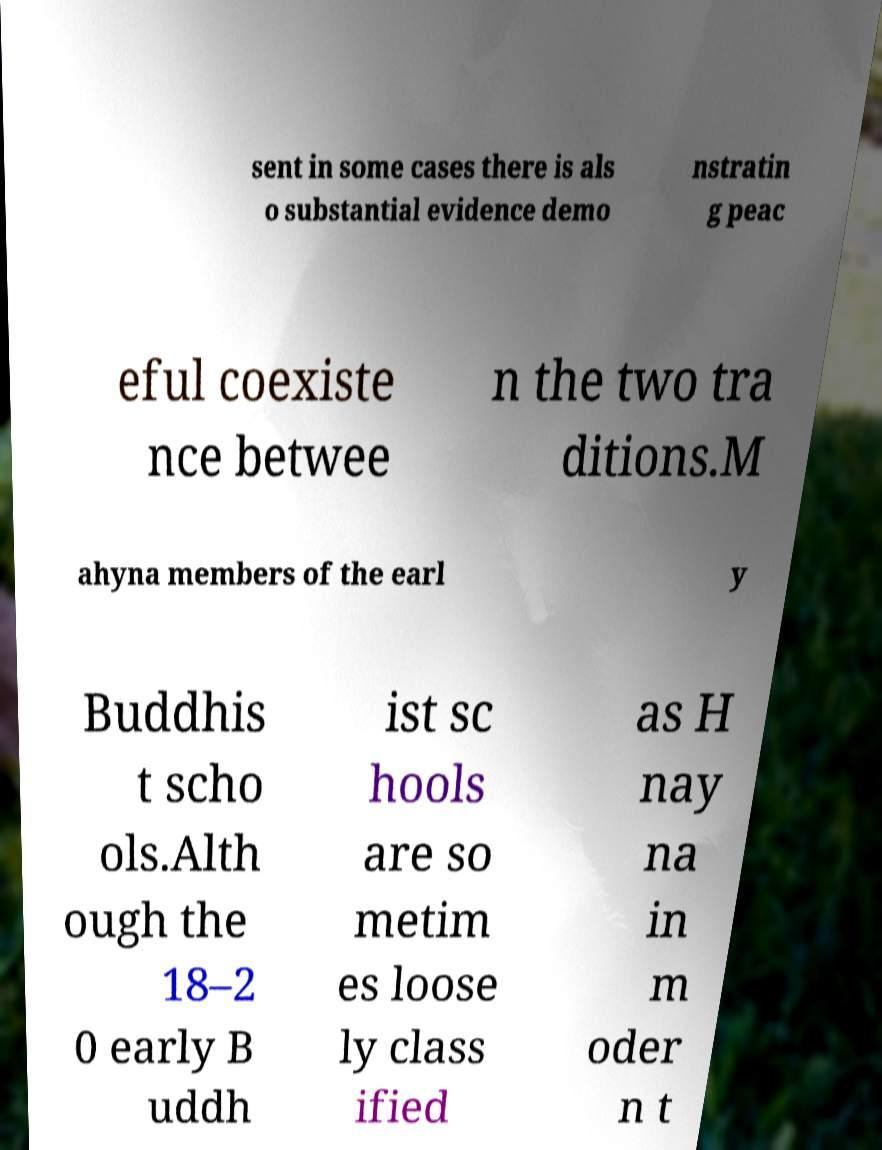There's text embedded in this image that I need extracted. Can you transcribe it verbatim? sent in some cases there is als o substantial evidence demo nstratin g peac eful coexiste nce betwee n the two tra ditions.M ahyna members of the earl y Buddhis t scho ols.Alth ough the 18–2 0 early B uddh ist sc hools are so metim es loose ly class ified as H nay na in m oder n t 